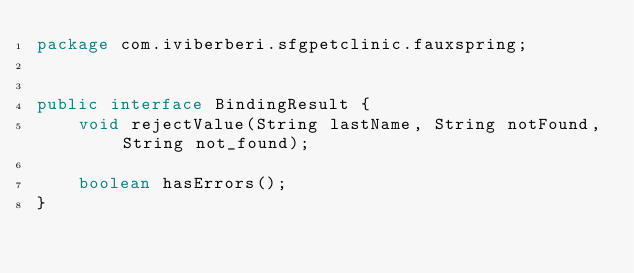<code> <loc_0><loc_0><loc_500><loc_500><_Java_>package com.iviberberi.sfgpetclinic.fauxspring;


public interface BindingResult {
    void rejectValue(String lastName, String notFound, String not_found);

    boolean hasErrors();
}
</code> 